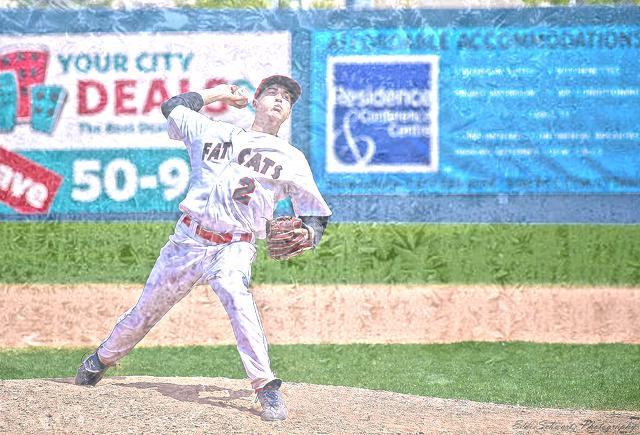What is the expression of the player? The player has a focused and intense expression, indicating concentration and determination during the game. 